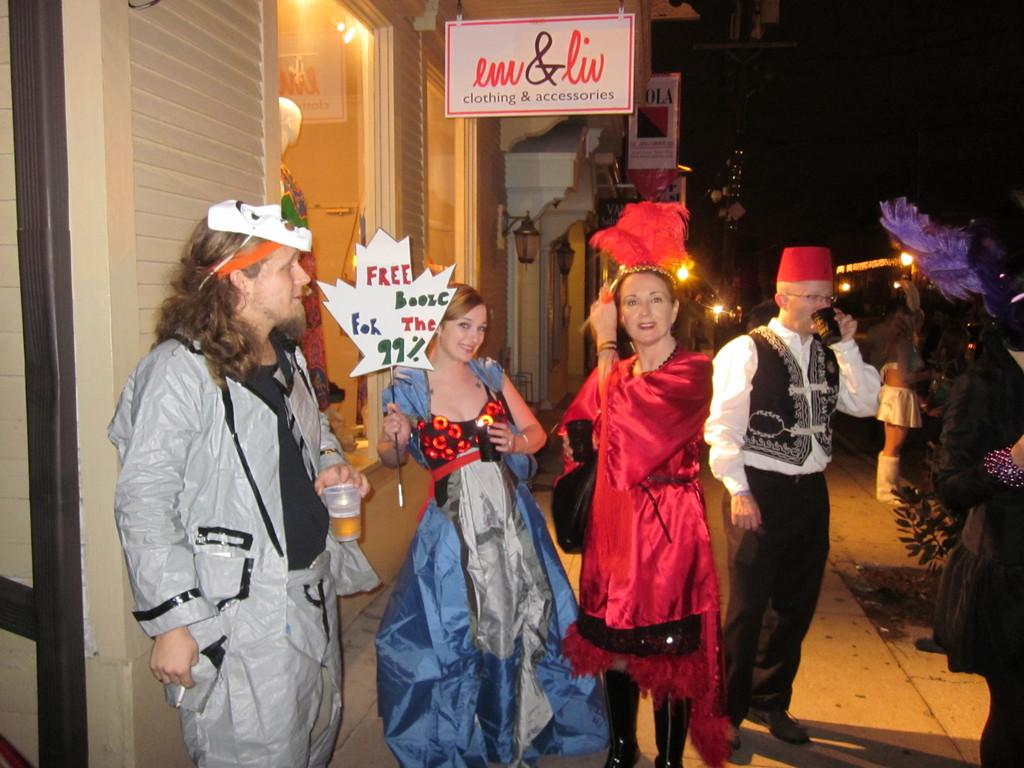What is happening in the image? There are people standing in the image, wearing different costumes and holding glass and boards. What can be seen in the background of the image? There are buildings and lights visible in the background. Can you describe the mannequin doll in the image? There is a mannequin doll in the image. How many horses are present in the image? There are no horses present in the image. What type of rock is being used as a prop in the image? There is no rock present in the image. 